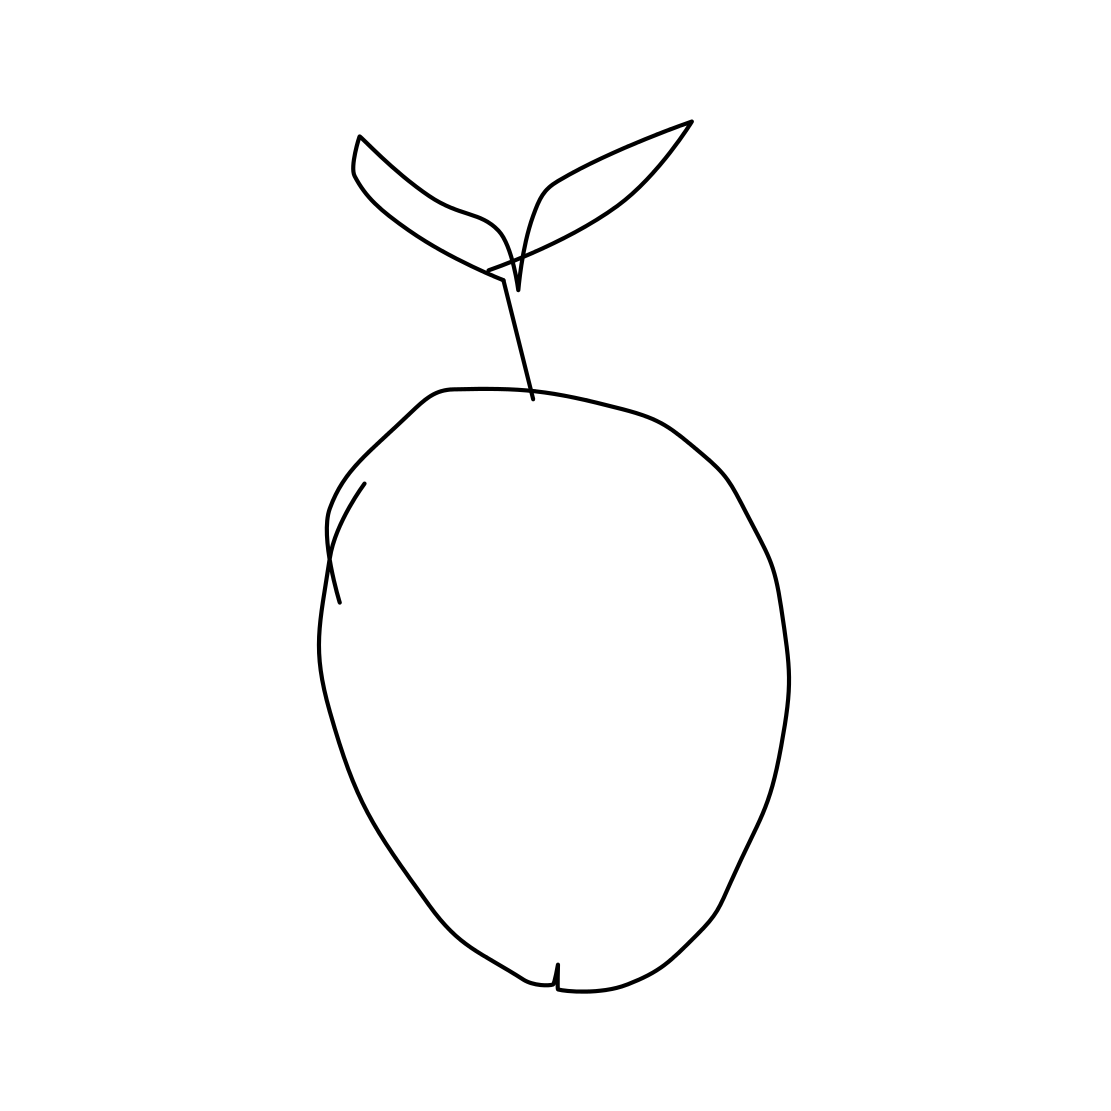In the scene, is a crab in it? No, there is no crab in the image. The image solely features an outline drawing of an apple with two leaves sprouting from its stem. 